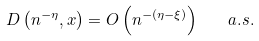Convert formula to latex. <formula><loc_0><loc_0><loc_500><loc_500>D \left ( n ^ { - \eta } , x \right ) = O \left ( n ^ { - ( \eta - \xi ) } \right ) \quad a . s .</formula> 